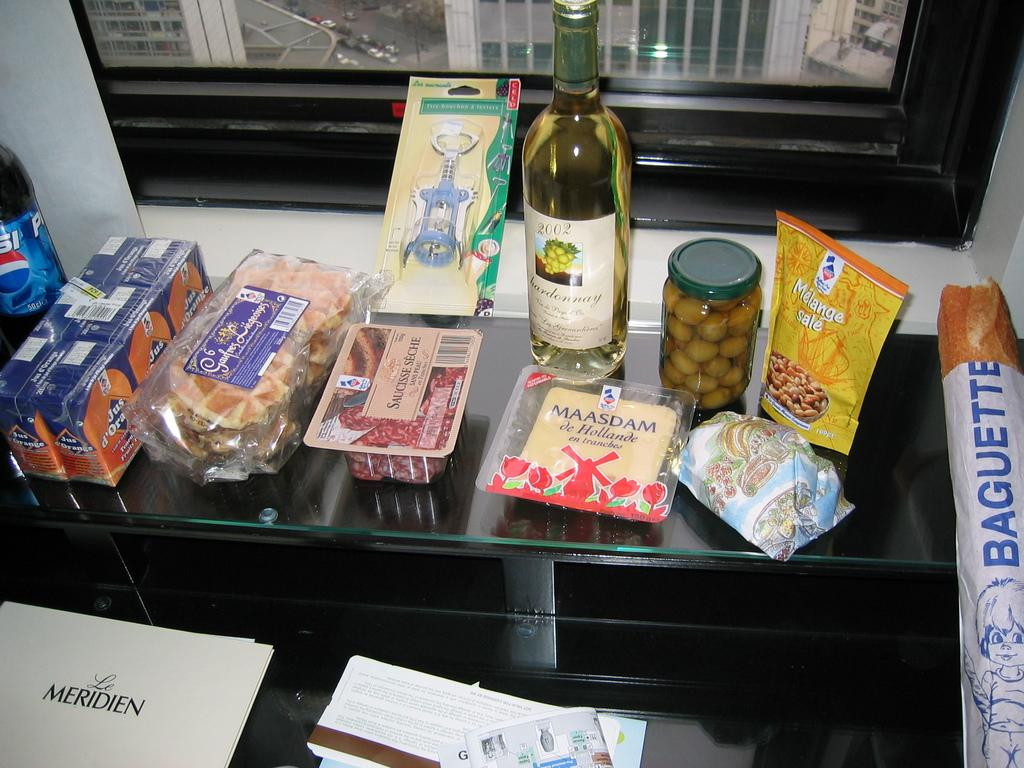What type of items can be seen on the table in the image? There are packaged food items and a cool drink bottle on the table. Is there any alcoholic beverage present on the table? Yes, there is a wine bottle on the table. Where is the stove located in the image? There is no stove present in the image. What type of root can be seen growing near the wine bottle? There are no roots present in the image. 